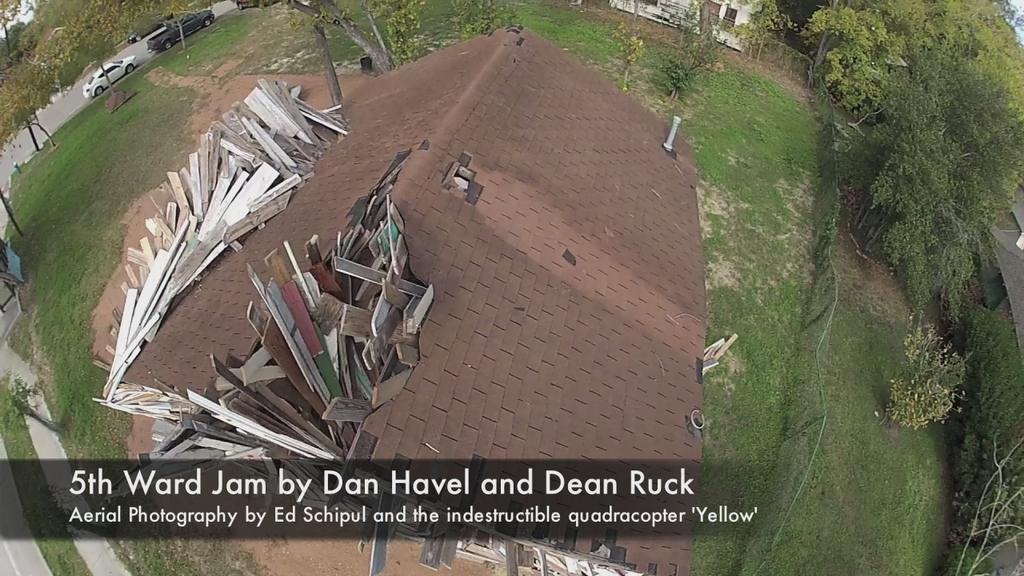In one or two sentences, can you explain what this image depicts? In this image we can see a house with a roof, wooden pieces, grass, some plants, a group of trees, some vehicles on the ground and the sky. 